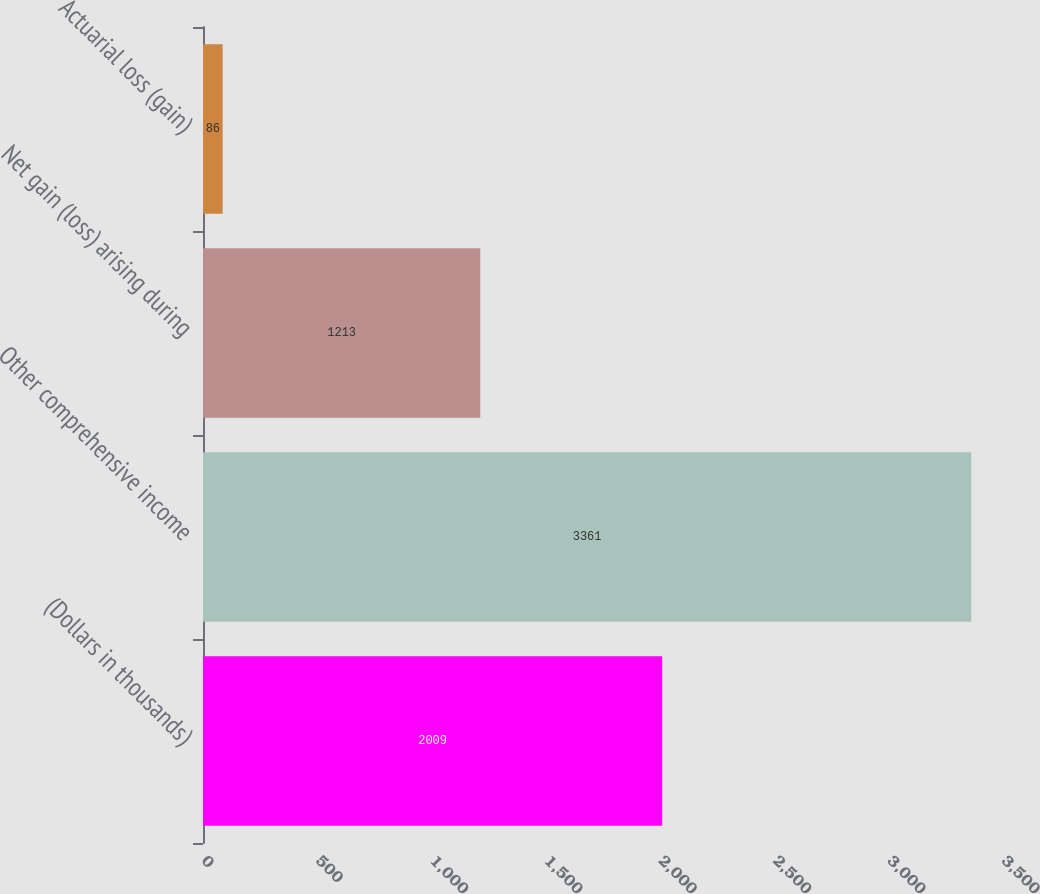<chart> <loc_0><loc_0><loc_500><loc_500><bar_chart><fcel>(Dollars in thousands)<fcel>Other comprehensive income<fcel>Net gain (loss) arising during<fcel>Actuarial loss (gain)<nl><fcel>2009<fcel>3361<fcel>1213<fcel>86<nl></chart> 